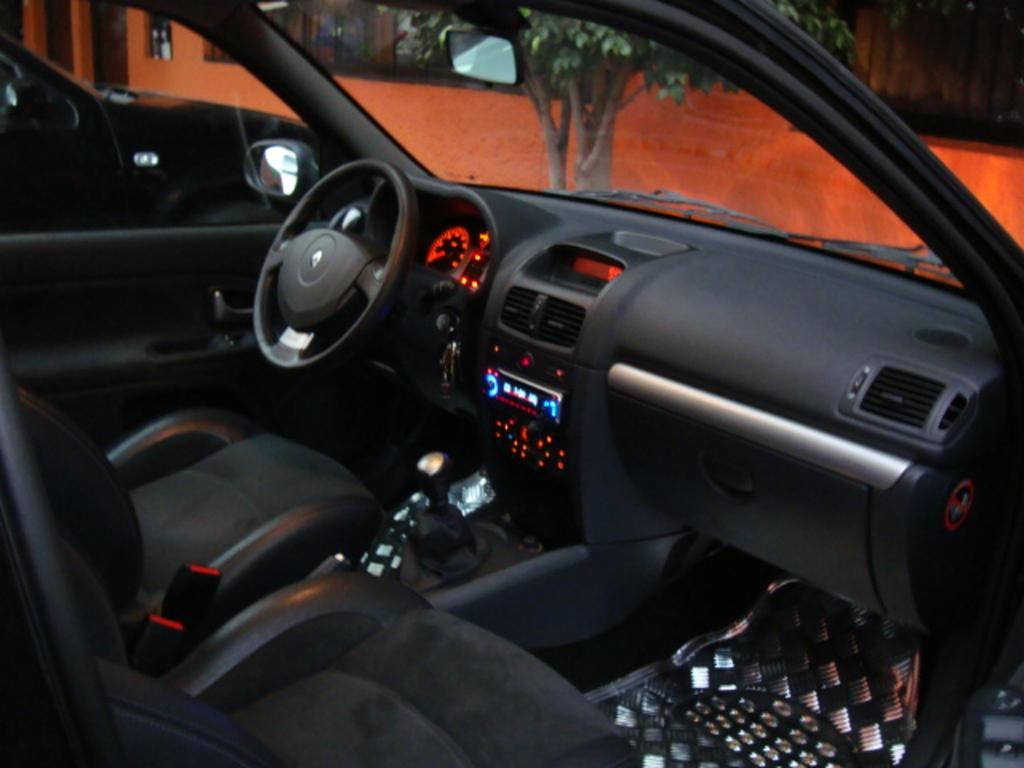What type of environment is depicted in the image? The image shows an inside view of a car. What can be seen through the glass in the car? A tree is visible through the glass. What is the primary control mechanism in the car? There is a steering wheel in the car. Where is the giraffe sitting in the car? There is no giraffe present in the image. What type of surprise is waiting for the driver in the car? The image does not depict any surprises for the driver. 